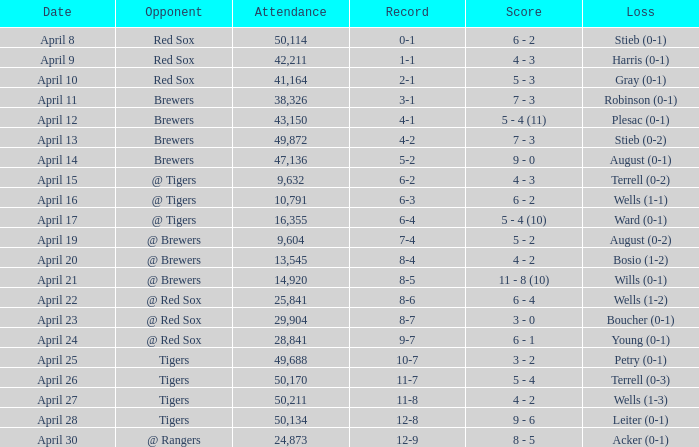Which rival has a decrease in wells (1-3)? Tigers. 